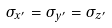<formula> <loc_0><loc_0><loc_500><loc_500>\sigma _ { x ^ { \prime } } = \sigma _ { y ^ { \prime } } = \sigma _ { z ^ { \prime } }</formula> 